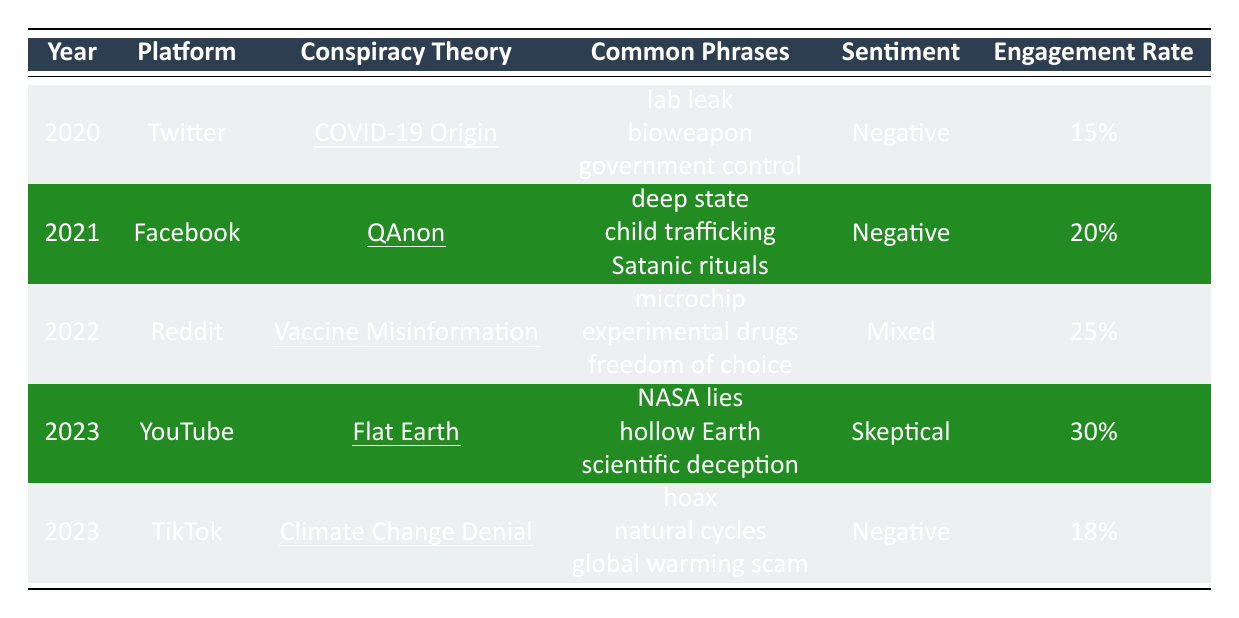What conspiracy theory was discussed on Twitter in 2020? The table indicates that the conspiracy theory discussed on Twitter in 2020 was "COVID-19 Origin."
Answer: COVID-19 Origin Which platform had the highest engagement rate in 2023? By comparing the engagement rates for 2023, YouTube has the highest rate at 30%. TikTok has 18%.
Answer: YouTube What was the sentiment associated with the "Vaccine Misinformation" conspiracy theory? The table shows that the sentiment for "Vaccine Misinformation" in 2022 was labeled as "Mixed."
Answer: Mixed How does the engagement rate for "Climate Change Denial" compare to that of "QAnon"? The engagement rate for "Climate Change Denial" is 18%, while for "QAnon" it is 20%. "QAnon" has a higher engagement rate by 2%.
Answer: 2% Which conspiracy theory had the lowest engagement rate overall? By checking the engagement rates listed, "COVID-19 Origin" had the lowest engagement rate at 15%.
Answer: COVID-19 Origin True or False: The conspiracy theory "Flat Earth" has a negative sentiment. The table states that the sentiment for "Flat Earth" in 2023 is "Skeptical," which is neither negative nor positive. Therefore, the statement is false.
Answer: False What is the average engagement rate across all the conspiracy theories listed? To find the average, sum the engagement rates: 15% + 20% + 25% + 30% + 18% = 108%. Then divide by the number of entries, which is 5. The average is 108% / 5 = 21.6%.
Answer: 21.6% What were the common phrases associated with the "QAnon" theories? The table lists the common phrases for "QAnon" as "deep state," "child trafficking," and "Satanic rituals."
Answer: deep state, child trafficking, Satanic rituals In which year was the "Vaccine Misinformation" theory discussed, and what was its sentiment? The table indicates that "Vaccine Misinformation" was discussed in 2022, and its sentiment was "Mixed."
Answer: 2022, Mixed Compare the sentiments of "COVID-19 Origin" and "Climate Change Denial." Are they both negative? "COVID-19 Origin" has a negative sentiment, while "Climate Change Denial" is also negative. Both are negative.
Answer: Yes 